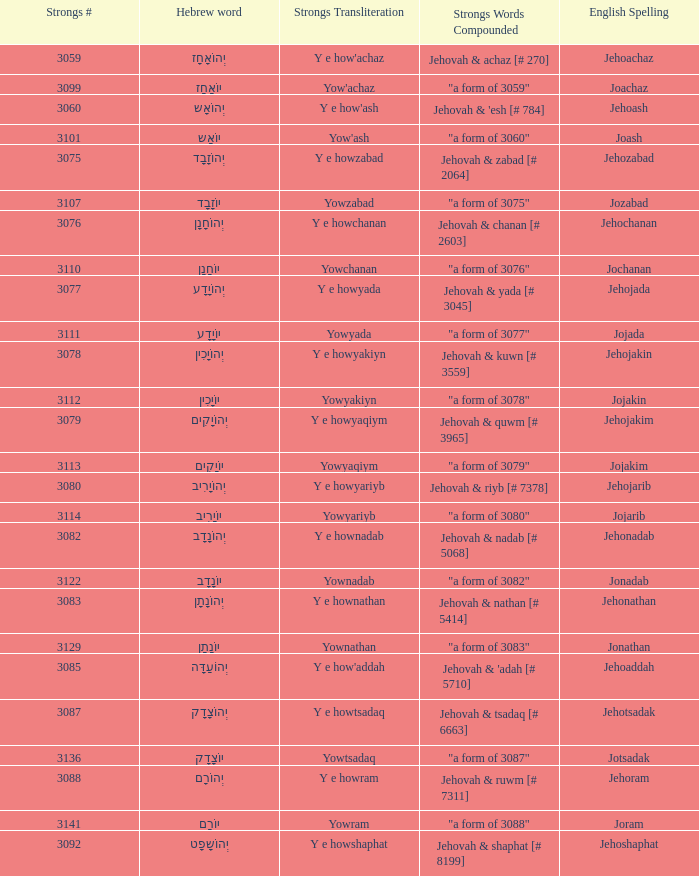What is the strongs transliteration of the hebrew word יוֹחָנָן? Yowchanan. 